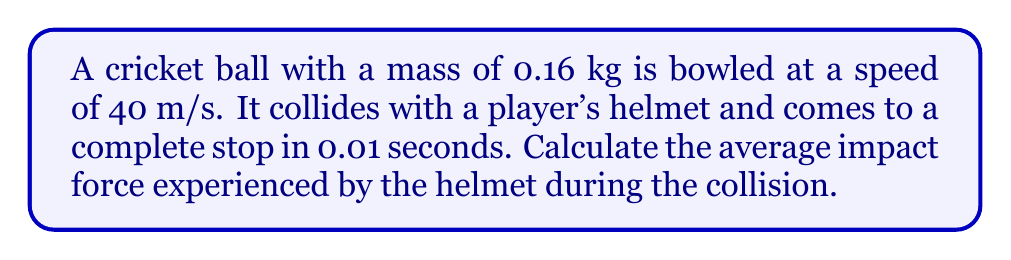Give your solution to this math problem. To solve this problem, we'll use the impulse-momentum theorem and Newton's Second Law of Motion. Let's break it down step-by-step:

1) First, we need to calculate the change in momentum of the cricket ball:
   Initial momentum: $p_i = mv_i = 0.16 \text{ kg} \times 40 \text{ m/s} = 6.4 \text{ kg}\cdot\text{m/s}$
   Final momentum: $p_f = mv_f = 0.16 \text{ kg} \times 0 \text{ m/s} = 0 \text{ kg}\cdot\text{m/s}$
   Change in momentum: $\Delta p = p_f - p_i = 0 - 6.4 = -6.4 \text{ kg}\cdot\text{m/s}$

2) The impulse-momentum theorem states that the change in momentum equals the impulse:
   $\Delta p = F\Delta t$
   Where $F$ is the average force and $\Delta t$ is the time interval.

3) We can rearrange this equation to solve for the force:
   $F = \frac{\Delta p}{\Delta t}$

4) Now we can plug in our values:
   $F = \frac{-6.4 \text{ kg}\cdot\text{m/s}}{0.01 \text{ s}}$

5) Calculating the result:
   $F = -640 \text{ N}$

6) The negative sign indicates that the force is in the opposite direction of the initial velocity. For the magnitude of the force, we take the absolute value:
   $|F| = 640 \text{ N}$

Therefore, the average impact force experienced by the helmet during the collision is 640 N.
Answer: 640 N 